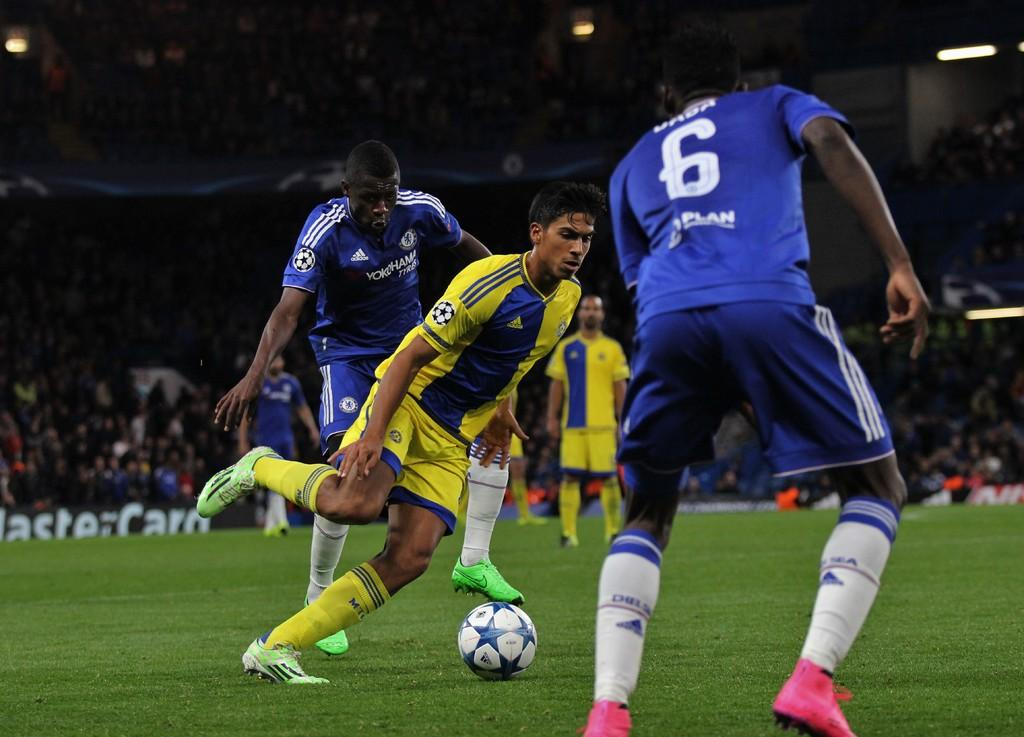What are the persons in the image doing? The persons in the image are running. Can you describe the person who is not running? There is a person standing in the image. What is on the grass in the image? There is a ball on the grass in the image. What can be seen in the background of the image? There is an audience and banners visible in the background of the image. What is visible at the top of the image? There are lights visible at the top of the image. What type of shame can be seen on the person's face in the image? There is no indication of shame or any emotion on the person's face in the image. What kind of bag is being used to carry the feast in the image? There is no bag or feast present in the image. 